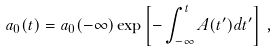Convert formula to latex. <formula><loc_0><loc_0><loc_500><loc_500>a _ { 0 } ( t ) = a _ { 0 } ( - \infty ) \exp \left [ - \int _ { - \infty } ^ { t } A ( t ^ { \prime } ) d t ^ { \prime } \right ] \, ,</formula> 